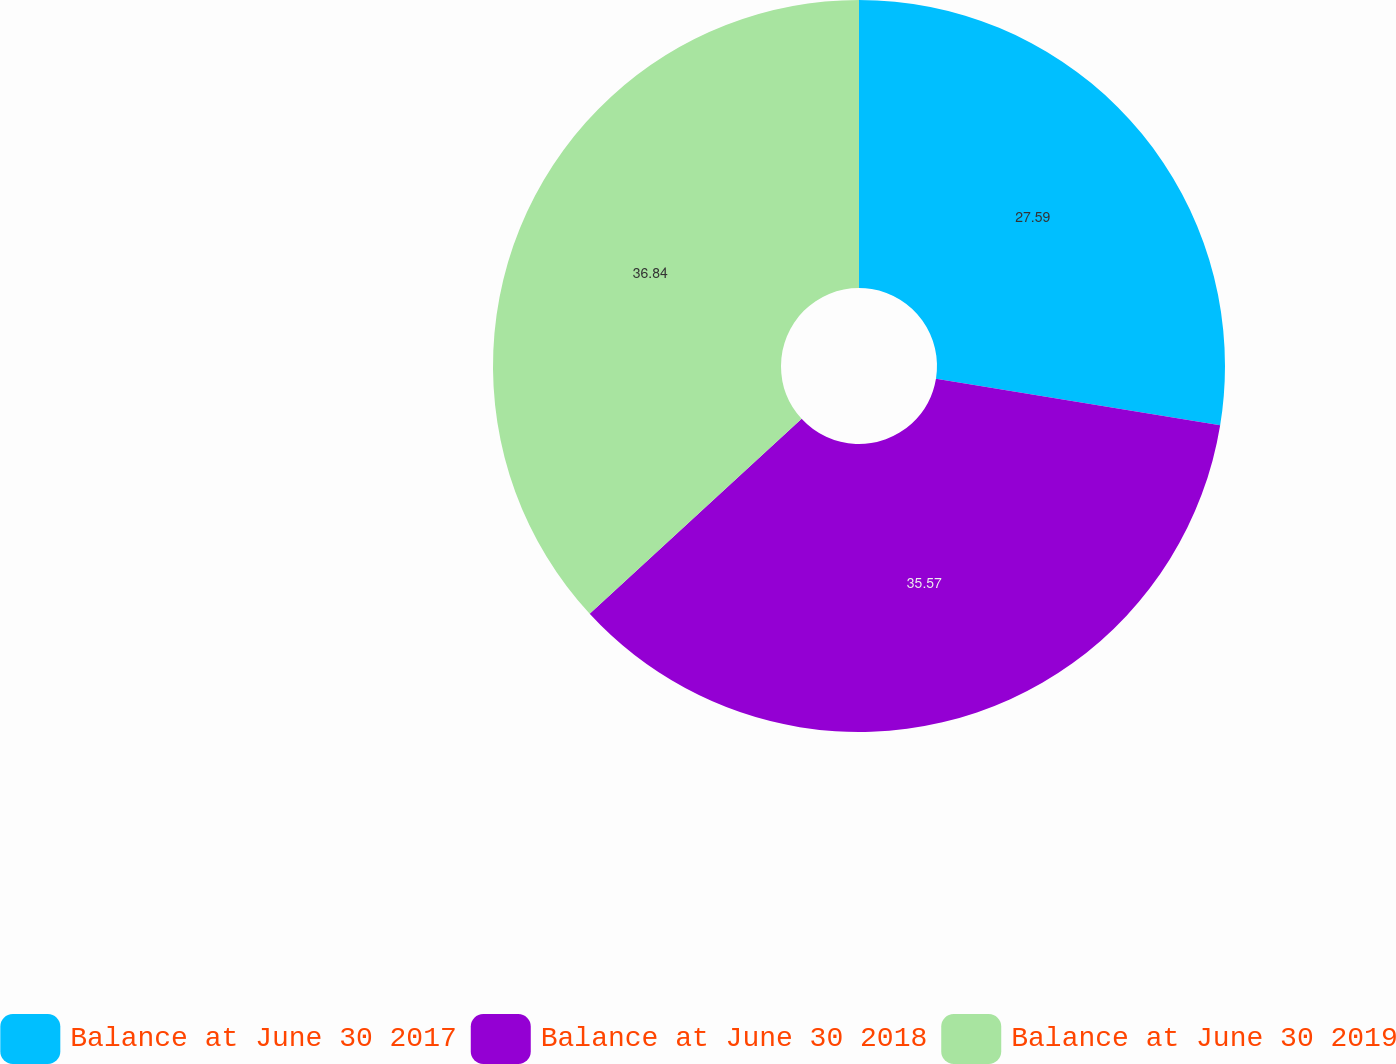Convert chart. <chart><loc_0><loc_0><loc_500><loc_500><pie_chart><fcel>Balance at June 30 2017<fcel>Balance at June 30 2018<fcel>Balance at June 30 2019<nl><fcel>27.59%<fcel>35.57%<fcel>36.84%<nl></chart> 